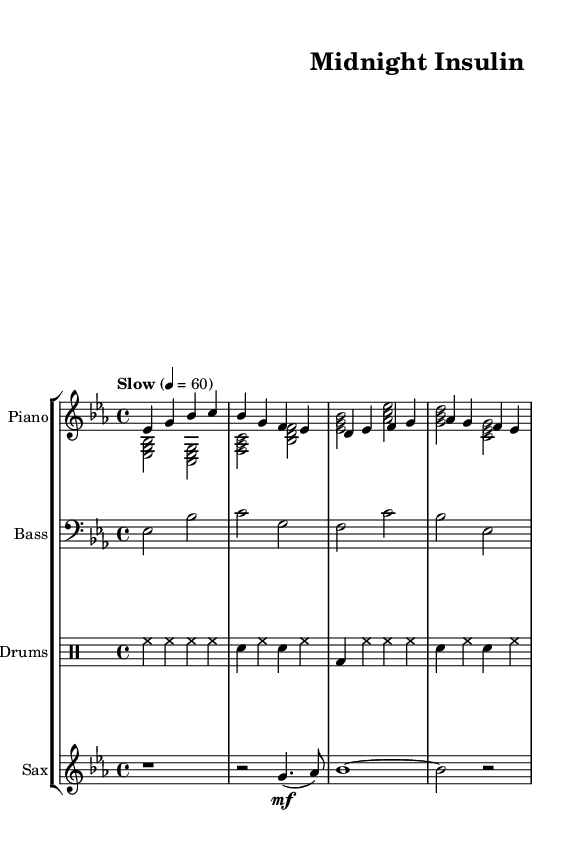What is the key signature of this music? The key signature is E flat major, indicated by three flats in the key signature.
Answer: E flat major What is the time signature of this piece? The time signature is indicated at the beginning of the score, and it shows a 4 over 4, meaning there are four beats per measure.
Answer: 4/4 What tempo marking is given for this piece? The tempo marking is "Slow" with a specific indication of 60 beats per minute, which is written at the start of the piece.
Answer: Slow 60 How many measures does the piano right hand (RH) part have? By counting the lines of music in the piano RH part, there are a total of four measures indicated.
Answer: 4 What chord is played in the left hand (LH) during the first measure? The first measure shows a chord consisting of E flat, G, and B flat, representing a major chord.
Answer: E flat major Which instrument has the solo part indicated by rests at the beginning? The saxophone part has the first measure as rest, indicating that it will enter later in the piece.
Answer: Saxophone How many different instruments are included in this score? The score indicates the presence of four distinct instruments: Piano, Bass, Drums, and Saxophone. Count the individual staff sections to confirm this.
Answer: 4 instruments 